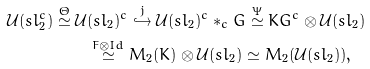Convert formula to latex. <formula><loc_0><loc_0><loc_500><loc_500>\mathcal { U } ( s l _ { 2 } ^ { c } ) \stackrel { \Theta } { \simeq } \mathcal { U } & ( s l _ { 2 } ) ^ { c } \stackrel { j } { \hookrightarrow } \mathcal { U } ( s l _ { 2 } ) ^ { c } * _ { c } G \stackrel { \Psi } { \simeq } K G ^ { c } \otimes \mathcal { U } ( s l _ { 2 } ) \\ & \stackrel { F \otimes I d } { \simeq } M _ { 2 } ( K ) \otimes \mathcal { U } ( s l _ { 2 } ) \simeq M _ { 2 } ( \mathcal { U } ( s l _ { 2 } ) ) ,</formula> 